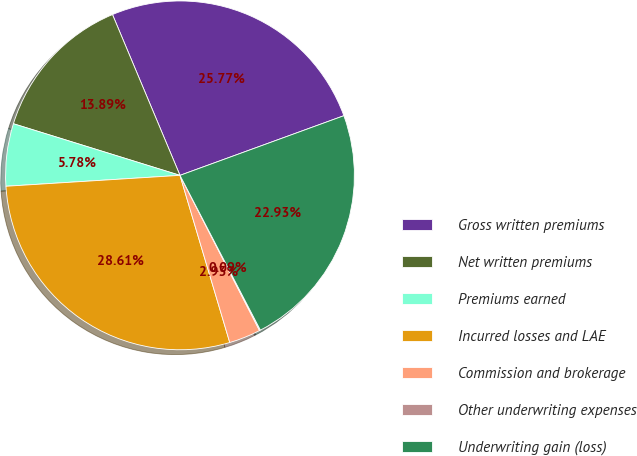Convert chart. <chart><loc_0><loc_0><loc_500><loc_500><pie_chart><fcel>Gross written premiums<fcel>Net written premiums<fcel>Premiums earned<fcel>Incurred losses and LAE<fcel>Commission and brokerage<fcel>Other underwriting expenses<fcel>Underwriting gain (loss)<nl><fcel>25.77%<fcel>13.89%<fcel>5.78%<fcel>28.61%<fcel>2.93%<fcel>0.09%<fcel>22.93%<nl></chart> 